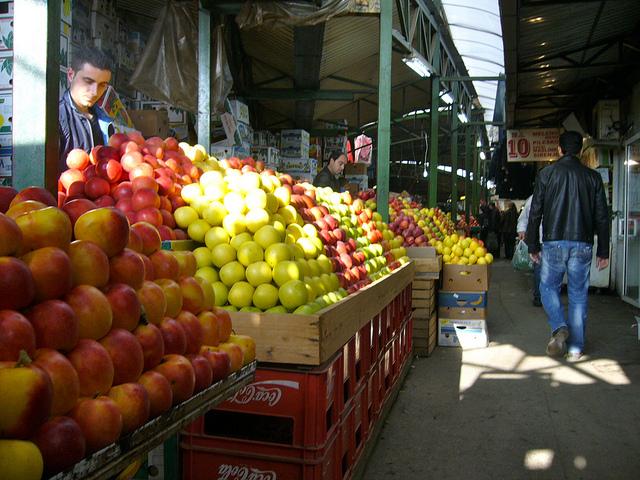What is the man wearing on his wrists?
Short answer required. Watch. Are these all apples?
Short answer required. Yes. What is the shop selling?
Quick response, please. Fruit. What color are the apples?
Quick response, please. Red and green. 